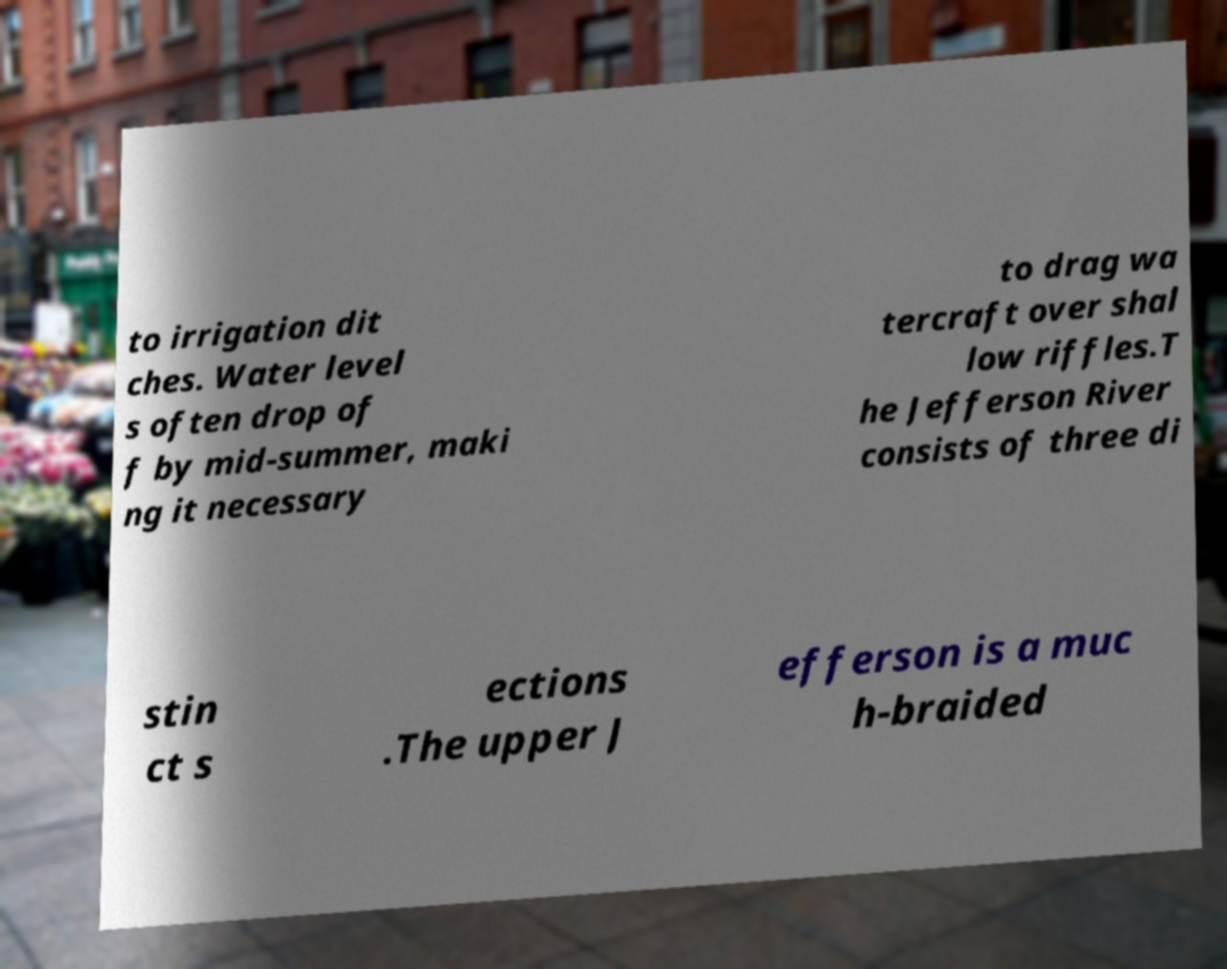I need the written content from this picture converted into text. Can you do that? to irrigation dit ches. Water level s often drop of f by mid-summer, maki ng it necessary to drag wa tercraft over shal low riffles.T he Jefferson River consists of three di stin ct s ections .The upper J efferson is a muc h-braided 